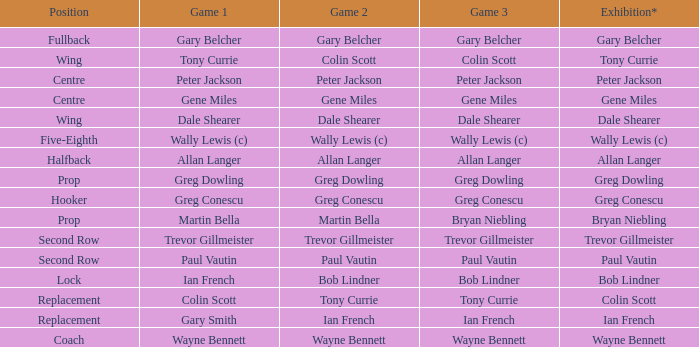What game 1 includes bob lindner as in game 2? Ian French. 